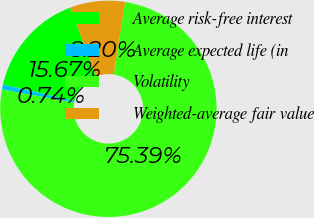Convert chart. <chart><loc_0><loc_0><loc_500><loc_500><pie_chart><fcel>Average risk-free interest<fcel>Average expected life (in<fcel>Volatility<fcel>Weighted-average fair value<nl><fcel>15.67%<fcel>0.74%<fcel>75.39%<fcel>8.2%<nl></chart> 